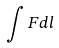<formula> <loc_0><loc_0><loc_500><loc_500>\int F d l</formula> 